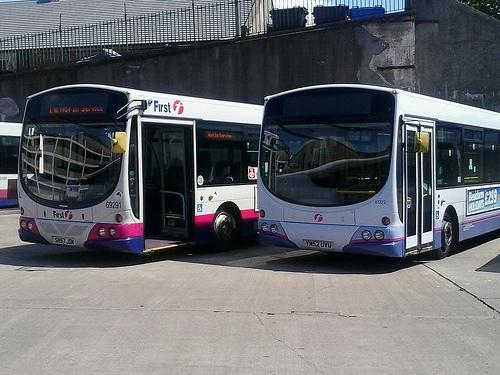Find any accessibility features present on the bus and describe them. There is a handicap sticker on the bus, as well as a blue handicap sign, indicating that the bus is equipped for wheelchair accessibility or passengers with disabilities. In a detailed manner, describe the image setting, mentioning the presence of vehicles and the ground conditions. The image shows two buses parked in a bus stand, one red and white bus and one blue and white bus, with various parts and features visible on their exteriors. The ground is made of concrete, and the sidewalk appears light grey in color. Identify the two main colors of the buses in the image. The two main colors of the buses are red and white, and blue and white. Can you see any windows on the side of the bus? If yes, describe them. Yes, there are side windows on the bus, and they appear as rectangular openings for passengers to see out of. Please list any distinct objects or features seen on the bus exterior. Front window, rear view window, front tire, headlight, side windows, handicap sticker, red stripe, black numbers, blue handicap sign, headlights with side indicator, number plate, main door, side mirror, front glass with wiper, top, electronic destination sign, head lights, wind shield, white doors, rubber tire, license plate, side window. Describe the sentiment or emotion evoked by the image, considering the presence of the buses and the surrounding environment. The sentiment evoked by the image is one of public transportation, mobility, and accessibility, as two buses are parked at a bus stand, ready for passengers to board and travel to their destinations. How many buses are parked in the bus stand area? There are two buses in the bus stand. Briefly describe what can be seen on the display board of a bus in the image. An electronic destination sign is present on the display board of a bus. What is the ground made of in this image? The ground is made of concrete. 